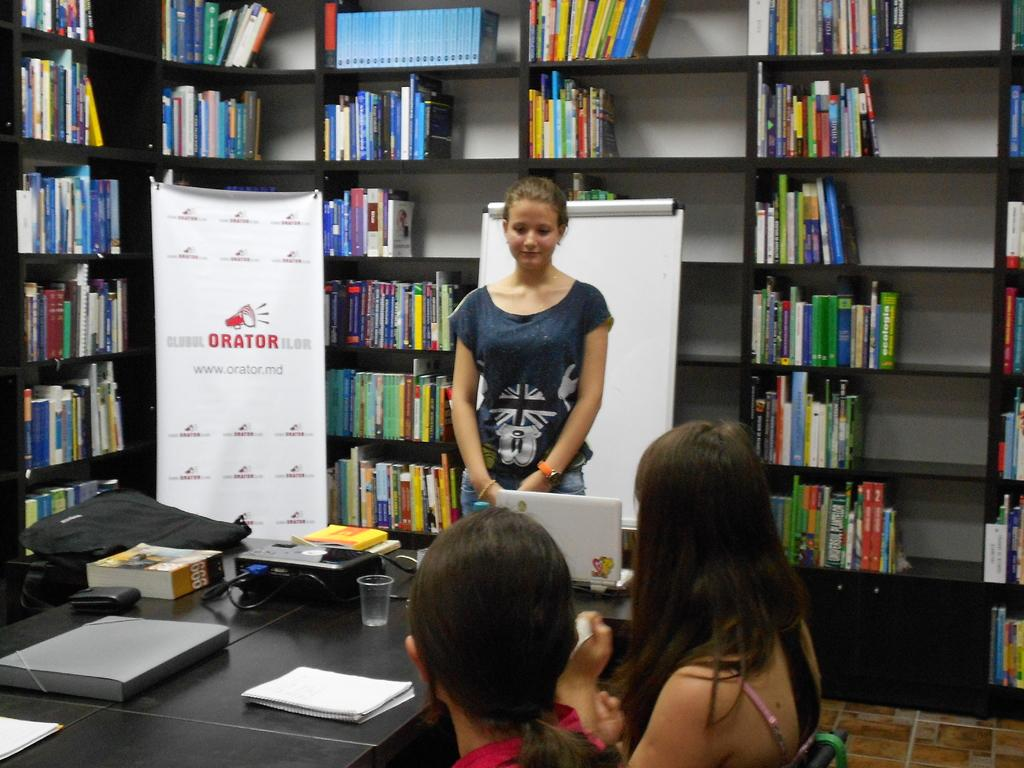Who is the main subject in the image? There is a girl in the image. What is the girl doing in the image? The girl is standing in front of a table. What is happening on the table in the image? Two people are sitting on the table. What can be seen in the background of the image? There are books visible in the background. How are the books arranged in the image? The books are kept on a wooden shelf. What type of lock is used to secure the nation in the image? There is no mention of a nation or a lock in the image. The image features a girl, a table, two people sitting on the table, and books on a wooden shelf in the background. 